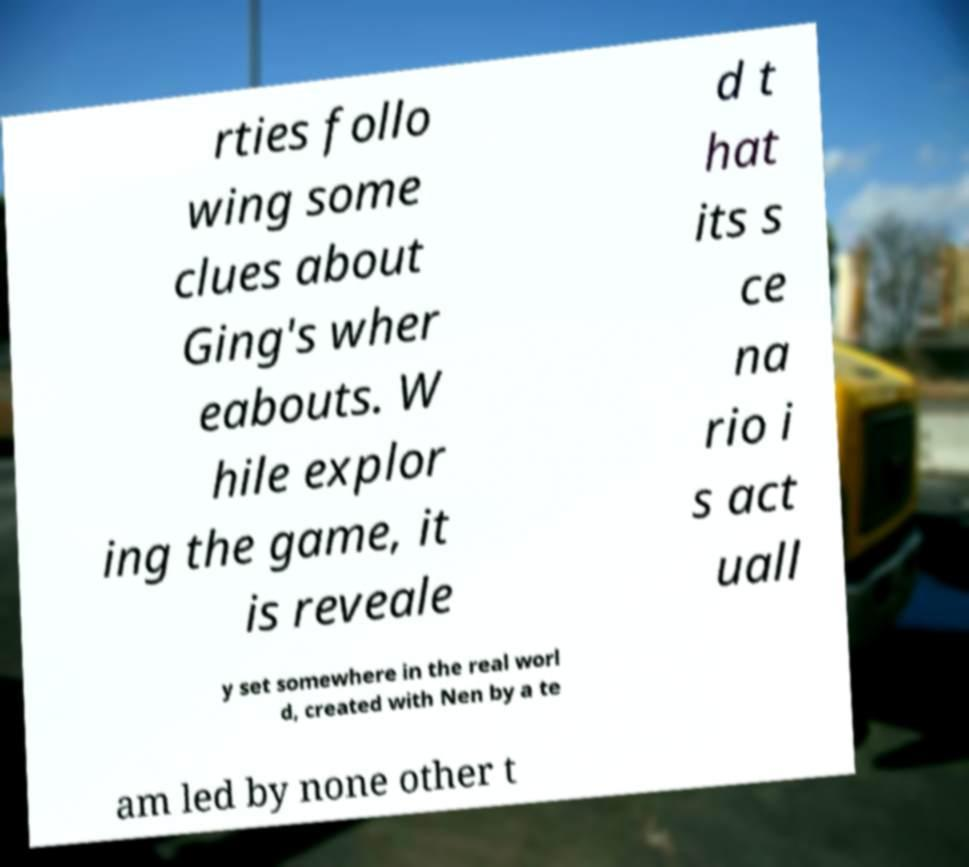There's text embedded in this image that I need extracted. Can you transcribe it verbatim? rties follo wing some clues about Ging's wher eabouts. W hile explor ing the game, it is reveale d t hat its s ce na rio i s act uall y set somewhere in the real worl d, created with Nen by a te am led by none other t 